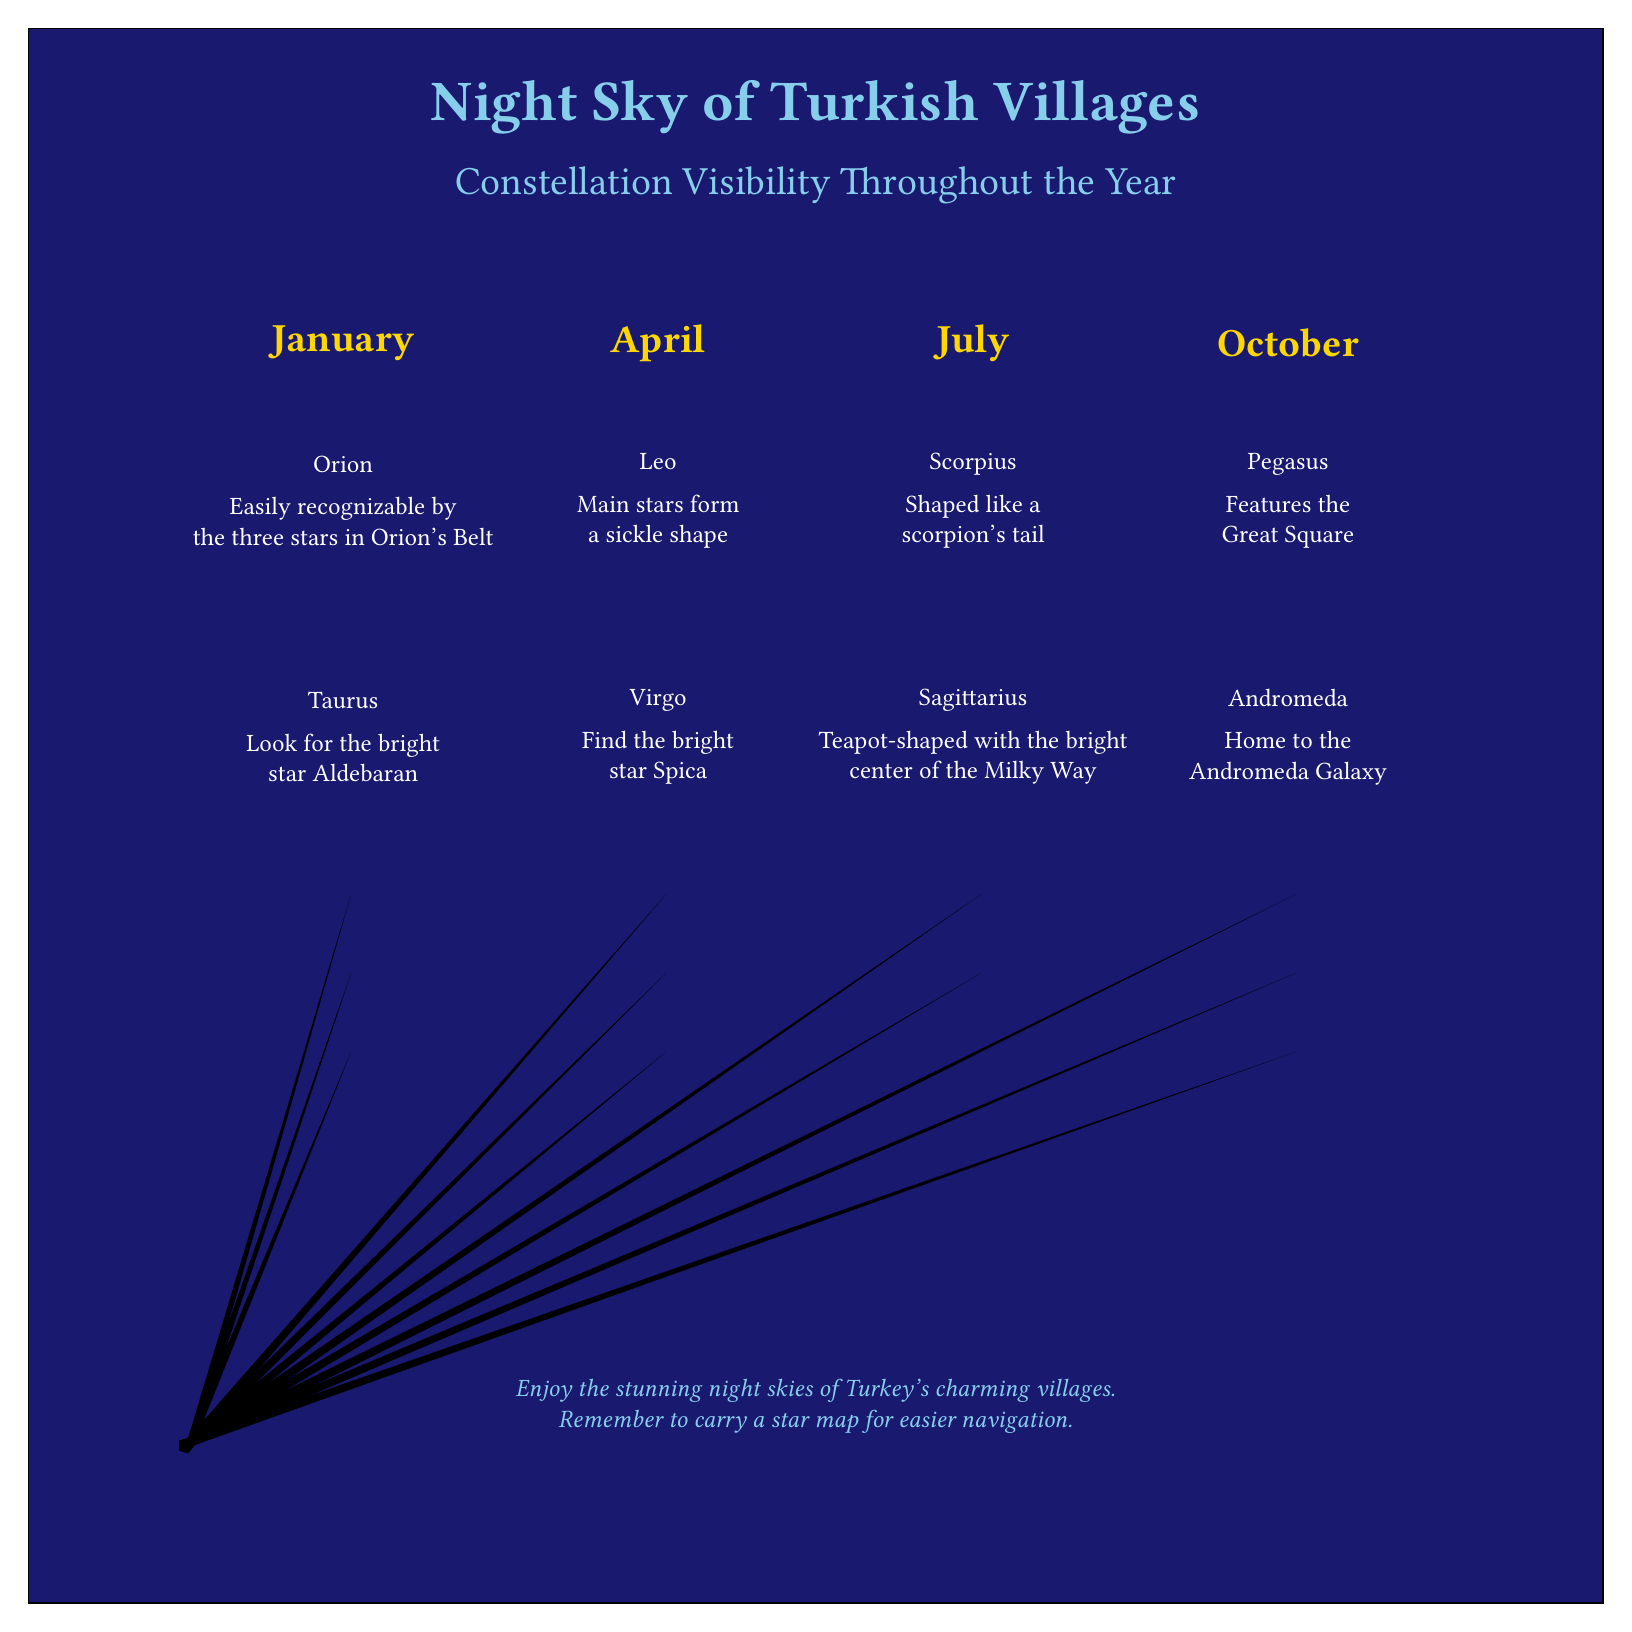What months are highlighted in the diagram? The diagram displays labels for four specific months: January, April, July, and October, each placed above the columns.
Answer: January, April, July, October Which constellation is represented in January? The diagram shows "Orion" under the January label, indicating that this constellation is visible during that month.
Answer: Orion Where can I find the bright star Aldebaran? The diagram indicates that "Aldebaran" is associated with the constellation "Taurus," which is placed under the April label.
Answer: Taurus Which two constellations can be seen in July? The diagram lists "Scorpius" and "Sagittarius" below the July label, meaning both of these constellations are visible during that month.
Answer: Scorpius, Sagittarius How many total constellations are illustrated in the diagram? Counting the constellations listed under each month (Orion, Taurus, Leo, Virgo, Scorpius, Sagittarius, Pegasus, Andromeda), there are a total of eight.
Answer: Eight What shape is associated with Leo in the diagram? The entry for Leo mentions that its main stars form a "sickle shape," indicating its distinctive appearance.
Answer: Sickle Which constellation contains the Andromeda Galaxy? The diagram shows "Andromeda" under its corresponding constellation description, highlighting its connection to the Andromeda Galaxy.
Answer: Andromeda What color is used for the background of the diagram? The background of the diagram is filled with the color "nightblue," which is specified in the diagram's code.
Answer: Nightblue What does the footer of the diagram advise travelers? The footer suggests carrying a star map for easier navigation when stargazing in Turkey's charming villages.
Answer: Carry a star map 